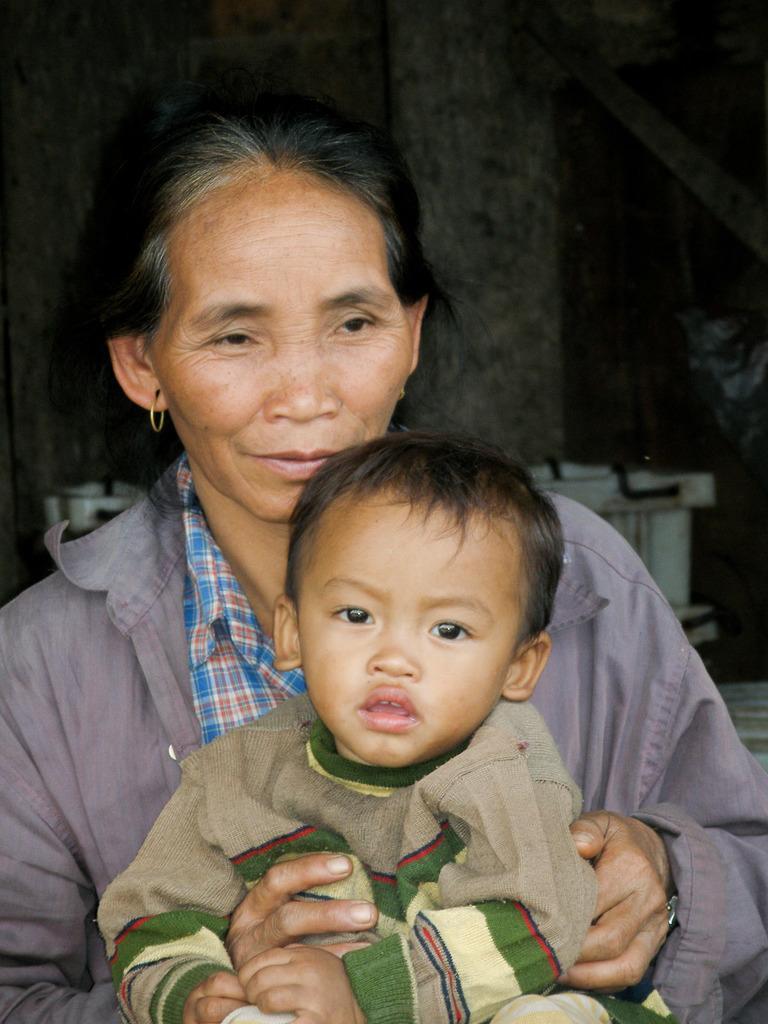Describe this image in one or two sentences. In this picture I can see a woman holding a boy, and in the background there are some objects. 